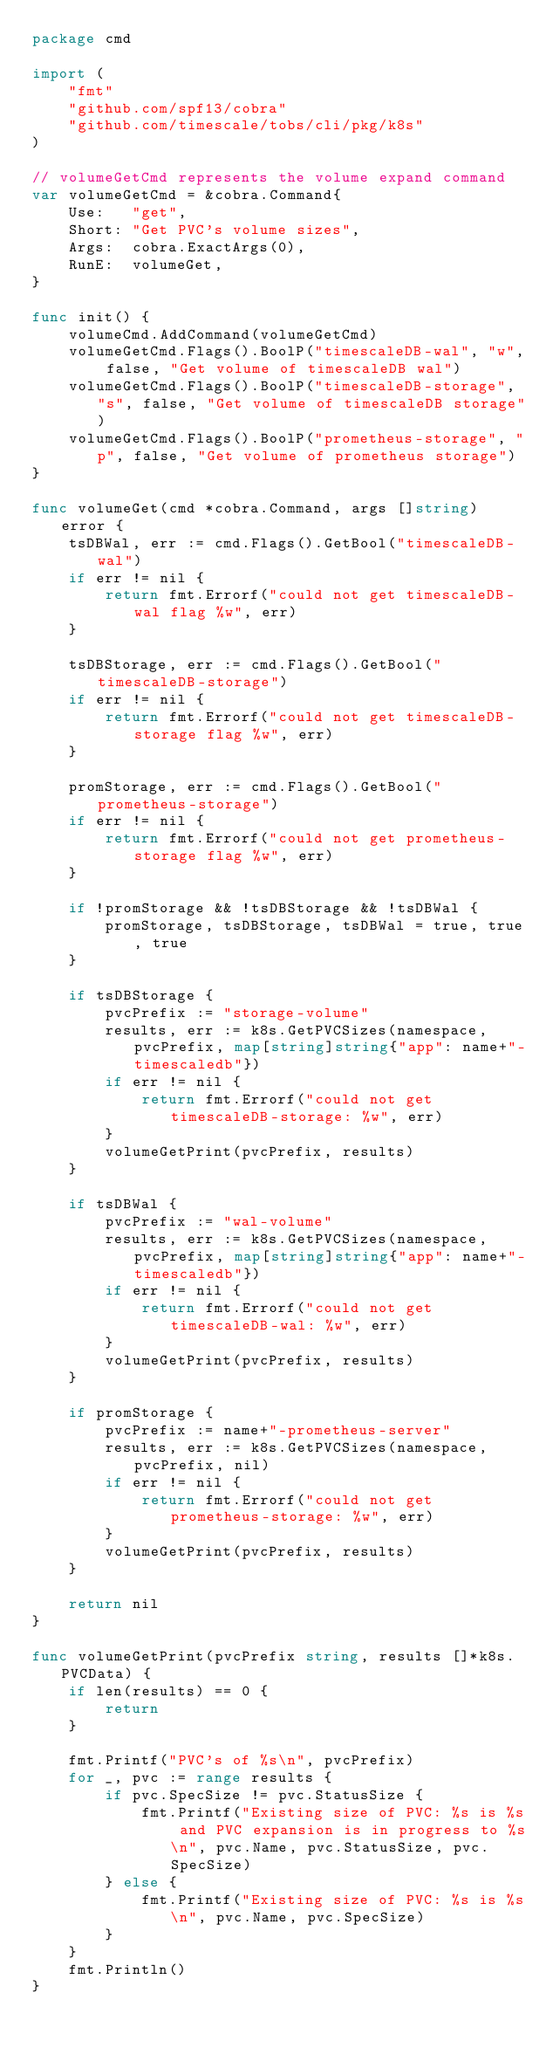<code> <loc_0><loc_0><loc_500><loc_500><_Go_>package cmd

import (
	"fmt"
	"github.com/spf13/cobra"
	"github.com/timescale/tobs/cli/pkg/k8s"
)

// volumeGetCmd represents the volume expand command
var volumeGetCmd = &cobra.Command{
	Use:   "get",
	Short: "Get PVC's volume sizes",
	Args:  cobra.ExactArgs(0),
	RunE:  volumeGet,
}

func init() {
	volumeCmd.AddCommand(volumeGetCmd)
	volumeGetCmd.Flags().BoolP("timescaleDB-wal", "w", false, "Get volume of timescaleDB wal")
	volumeGetCmd.Flags().BoolP("timescaleDB-storage", "s", false, "Get volume of timescaleDB storage")
	volumeGetCmd.Flags().BoolP("prometheus-storage", "p", false, "Get volume of prometheus storage")
}

func volumeGet(cmd *cobra.Command, args []string) error {
	tsDBWal, err := cmd.Flags().GetBool("timescaleDB-wal")
	if err != nil {
		return fmt.Errorf("could not get timescaleDB-wal flag %w", err)
	}

	tsDBStorage, err := cmd.Flags().GetBool("timescaleDB-storage")
	if err != nil {
		return fmt.Errorf("could not get timescaleDB-storage flag %w", err)
	}

	promStorage, err := cmd.Flags().GetBool("prometheus-storage")
	if err != nil {
		return fmt.Errorf("could not get prometheus-storage flag %w", err)
	}

	if !promStorage && !tsDBStorage && !tsDBWal {
		promStorage, tsDBStorage, tsDBWal = true, true, true
	}

	if tsDBStorage {
		pvcPrefix := "storage-volume"
		results, err := k8s.GetPVCSizes(namespace, pvcPrefix, map[string]string{"app": name+"-timescaledb"})
		if err != nil {
			return fmt.Errorf("could not get timescaleDB-storage: %w", err)
		}
		volumeGetPrint(pvcPrefix, results)
	}

	if tsDBWal {
		pvcPrefix := "wal-volume"
		results, err := k8s.GetPVCSizes(namespace, pvcPrefix, map[string]string{"app": name+"-timescaledb"})
		if err != nil {
			return fmt.Errorf("could not get timescaleDB-wal: %w", err)
		}
		volumeGetPrint(pvcPrefix, results)
	}

	if promStorage {
		pvcPrefix := name+"-prometheus-server"
		results, err := k8s.GetPVCSizes(namespace, pvcPrefix, nil)
		if err != nil {
			return fmt.Errorf("could not get prometheus-storage: %w", err)
		}
		volumeGetPrint(pvcPrefix, results)
	}

	return nil
}

func volumeGetPrint(pvcPrefix string, results []*k8s.PVCData) {
	if len(results) == 0 {
		return
	}

	fmt.Printf("PVC's of %s\n", pvcPrefix)
	for _, pvc := range results {
		if pvc.SpecSize != pvc.StatusSize {
			fmt.Printf("Existing size of PVC: %s is %s and PVC expansion is in progress to %s\n", pvc.Name, pvc.StatusSize, pvc.SpecSize)
		} else {
			fmt.Printf("Existing size of PVC: %s is %s\n", pvc.Name, pvc.SpecSize)
		}
	}
	fmt.Println()
}</code> 